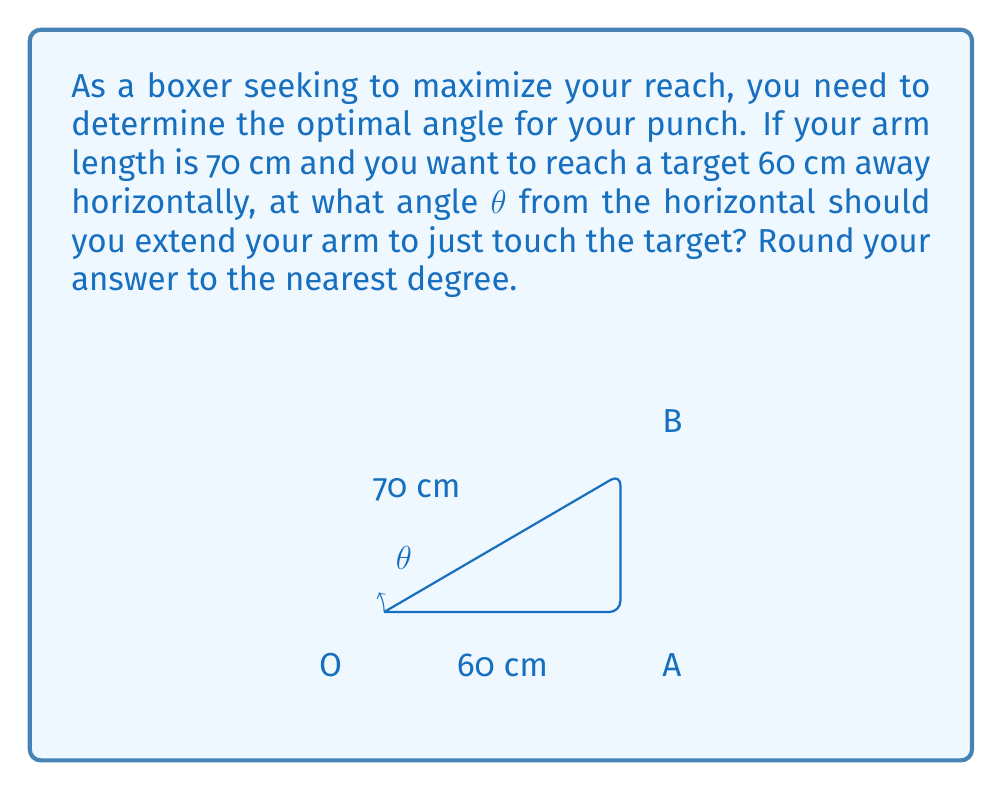Teach me how to tackle this problem. Let's approach this step-by-step using trigonometry:

1) We can view this as a right triangle problem, where:
   - The hypotenuse is your arm (70 cm)
   - The adjacent side to the angle θ is the horizontal distance (60 cm)
   - The opposite side is unknown

2) We can use the cosine function to solve for θ:

   $$\cos θ = \frac{\text{adjacent}}{\text{hypotenuse}} = \frac{60}{70}$$

3) To solve for θ, we take the inverse cosine (arccos) of both sides:

   $$θ = \arccos(\frac{60}{70})$$

4) Using a calculator or computer:

   $$θ ≈ 0.5033 \text{ radians}$$

5) Convert radians to degrees:

   $$θ ≈ 0.5033 \times \frac{180°}{\pi} ≈ 28.85°$$

6) Rounding to the nearest degree:

   $$θ ≈ 29°$$

Therefore, to maximize your reach for this specific target, you should extend your arm at an angle of approximately 29° from the horizontal.
Answer: 29° 